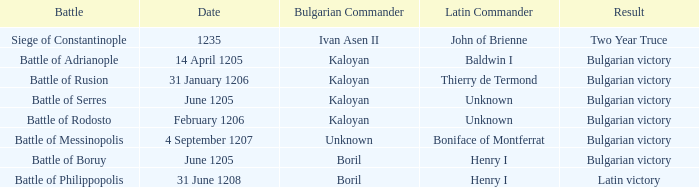What is the Result of the battle with Latin Commander Boniface of Montferrat? Bulgarian victory. 